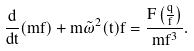<formula> <loc_0><loc_0><loc_500><loc_500>\frac { d } { d t } ( m \dot { f } ) + m \tilde { \omega } ^ { 2 } ( t ) f = \frac { F \left ( \frac { q } { f } \right ) } { m f ^ { 3 } } .</formula> 